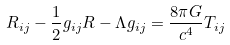Convert formula to latex. <formula><loc_0><loc_0><loc_500><loc_500>R _ { i j } - \frac { 1 } { 2 } g _ { i j } R - \Lambda g _ { i j } = \frac { 8 \pi G } { c ^ { 4 } } T _ { i j }</formula> 